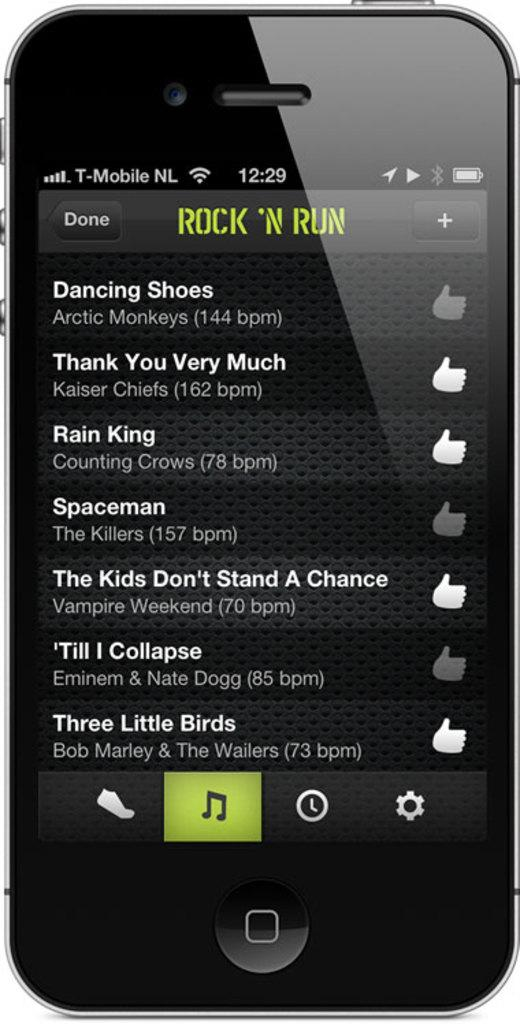<image>
Share a concise interpretation of the image provided. A black smartphone with an app open titled Rock N 